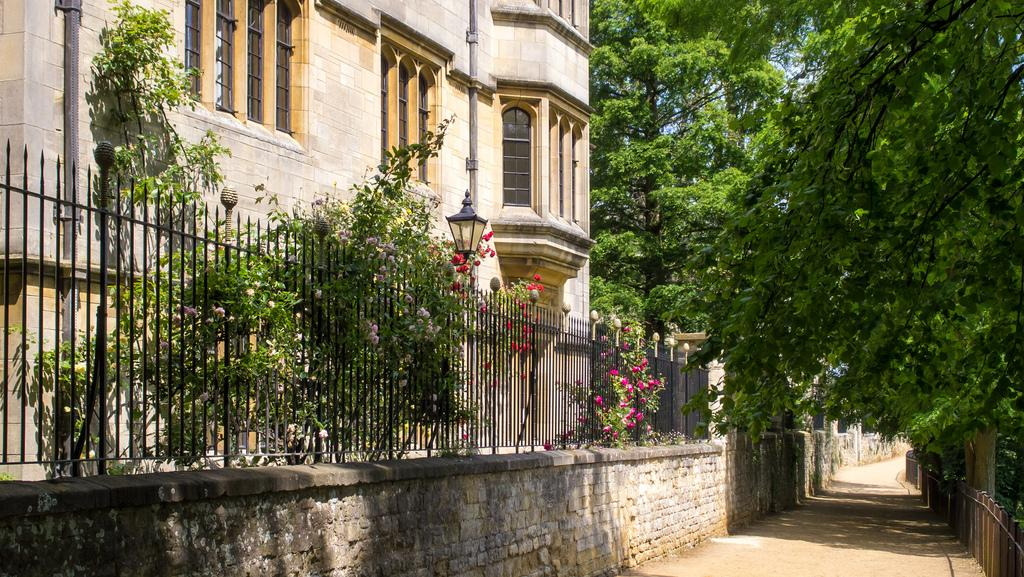What type of structure is visible in the image? There is a building with windows in the image. What natural elements can be seen in the image? There are trees in the image. What kind of surface is present in the image? There is a path in the image. What architectural feature is present in the image? There is a wall in the image. What can be seen in the background of the image? The sky is visible in the background of the image. What type of bell can be heard ringing in the image? There is no bell present in the image, and therefore no sound can be heard. 